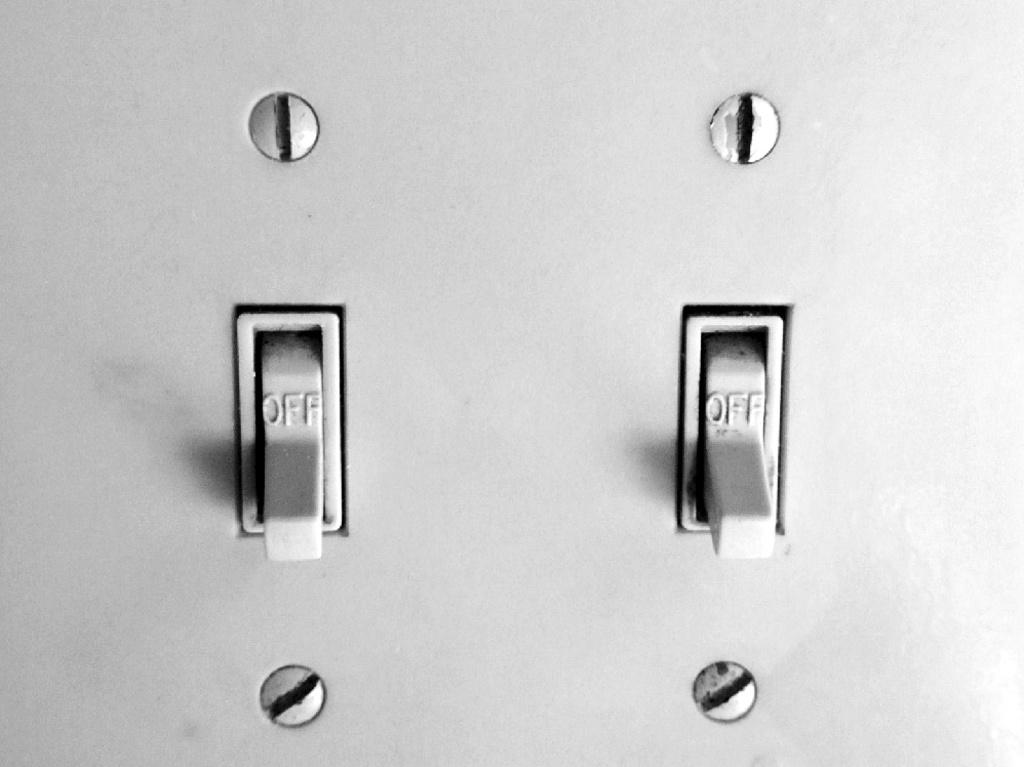Provide a one-sentence caption for the provided image. A double switch light sits against the wall with both switches in the off position. 